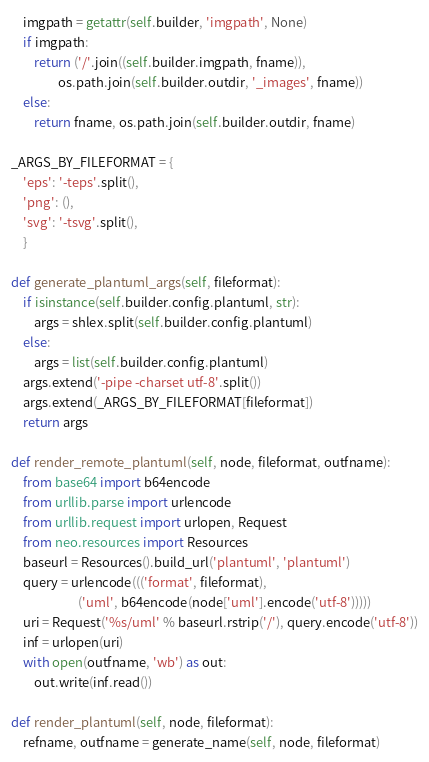Convert code to text. <code><loc_0><loc_0><loc_500><loc_500><_Python_>    imgpath = getattr(self.builder, 'imgpath', None)
    if imgpath:
        return ('/'.join((self.builder.imgpath, fname)),
                os.path.join(self.builder.outdir, '_images', fname))
    else:
        return fname, os.path.join(self.builder.outdir, fname)

_ARGS_BY_FILEFORMAT = {
    'eps': '-teps'.split(),
    'png': (),
    'svg': '-tsvg'.split(),
    }

def generate_plantuml_args(self, fileformat):
    if isinstance(self.builder.config.plantuml, str):
        args = shlex.split(self.builder.config.plantuml)
    else:
        args = list(self.builder.config.plantuml)
    args.extend('-pipe -charset utf-8'.split())
    args.extend(_ARGS_BY_FILEFORMAT[fileformat])
    return args

def render_remote_plantuml(self, node, fileformat, outfname):
    from base64 import b64encode
    from urllib.parse import urlencode
    from urllib.request import urlopen, Request
    from neo.resources import Resources
    baseurl = Resources().build_url('plantuml', 'plantuml')
    query = urlencode((('format', fileformat),
                       ('uml', b64encode(node['uml'].encode('utf-8')))))
    uri = Request('%s/uml' % baseurl.rstrip('/'), query.encode('utf-8'))
    inf = urlopen(uri)
    with open(outfname, 'wb') as out:
        out.write(inf.read())

def render_plantuml(self, node, fileformat):
    refname, outfname = generate_name(self, node, fileformat)</code> 